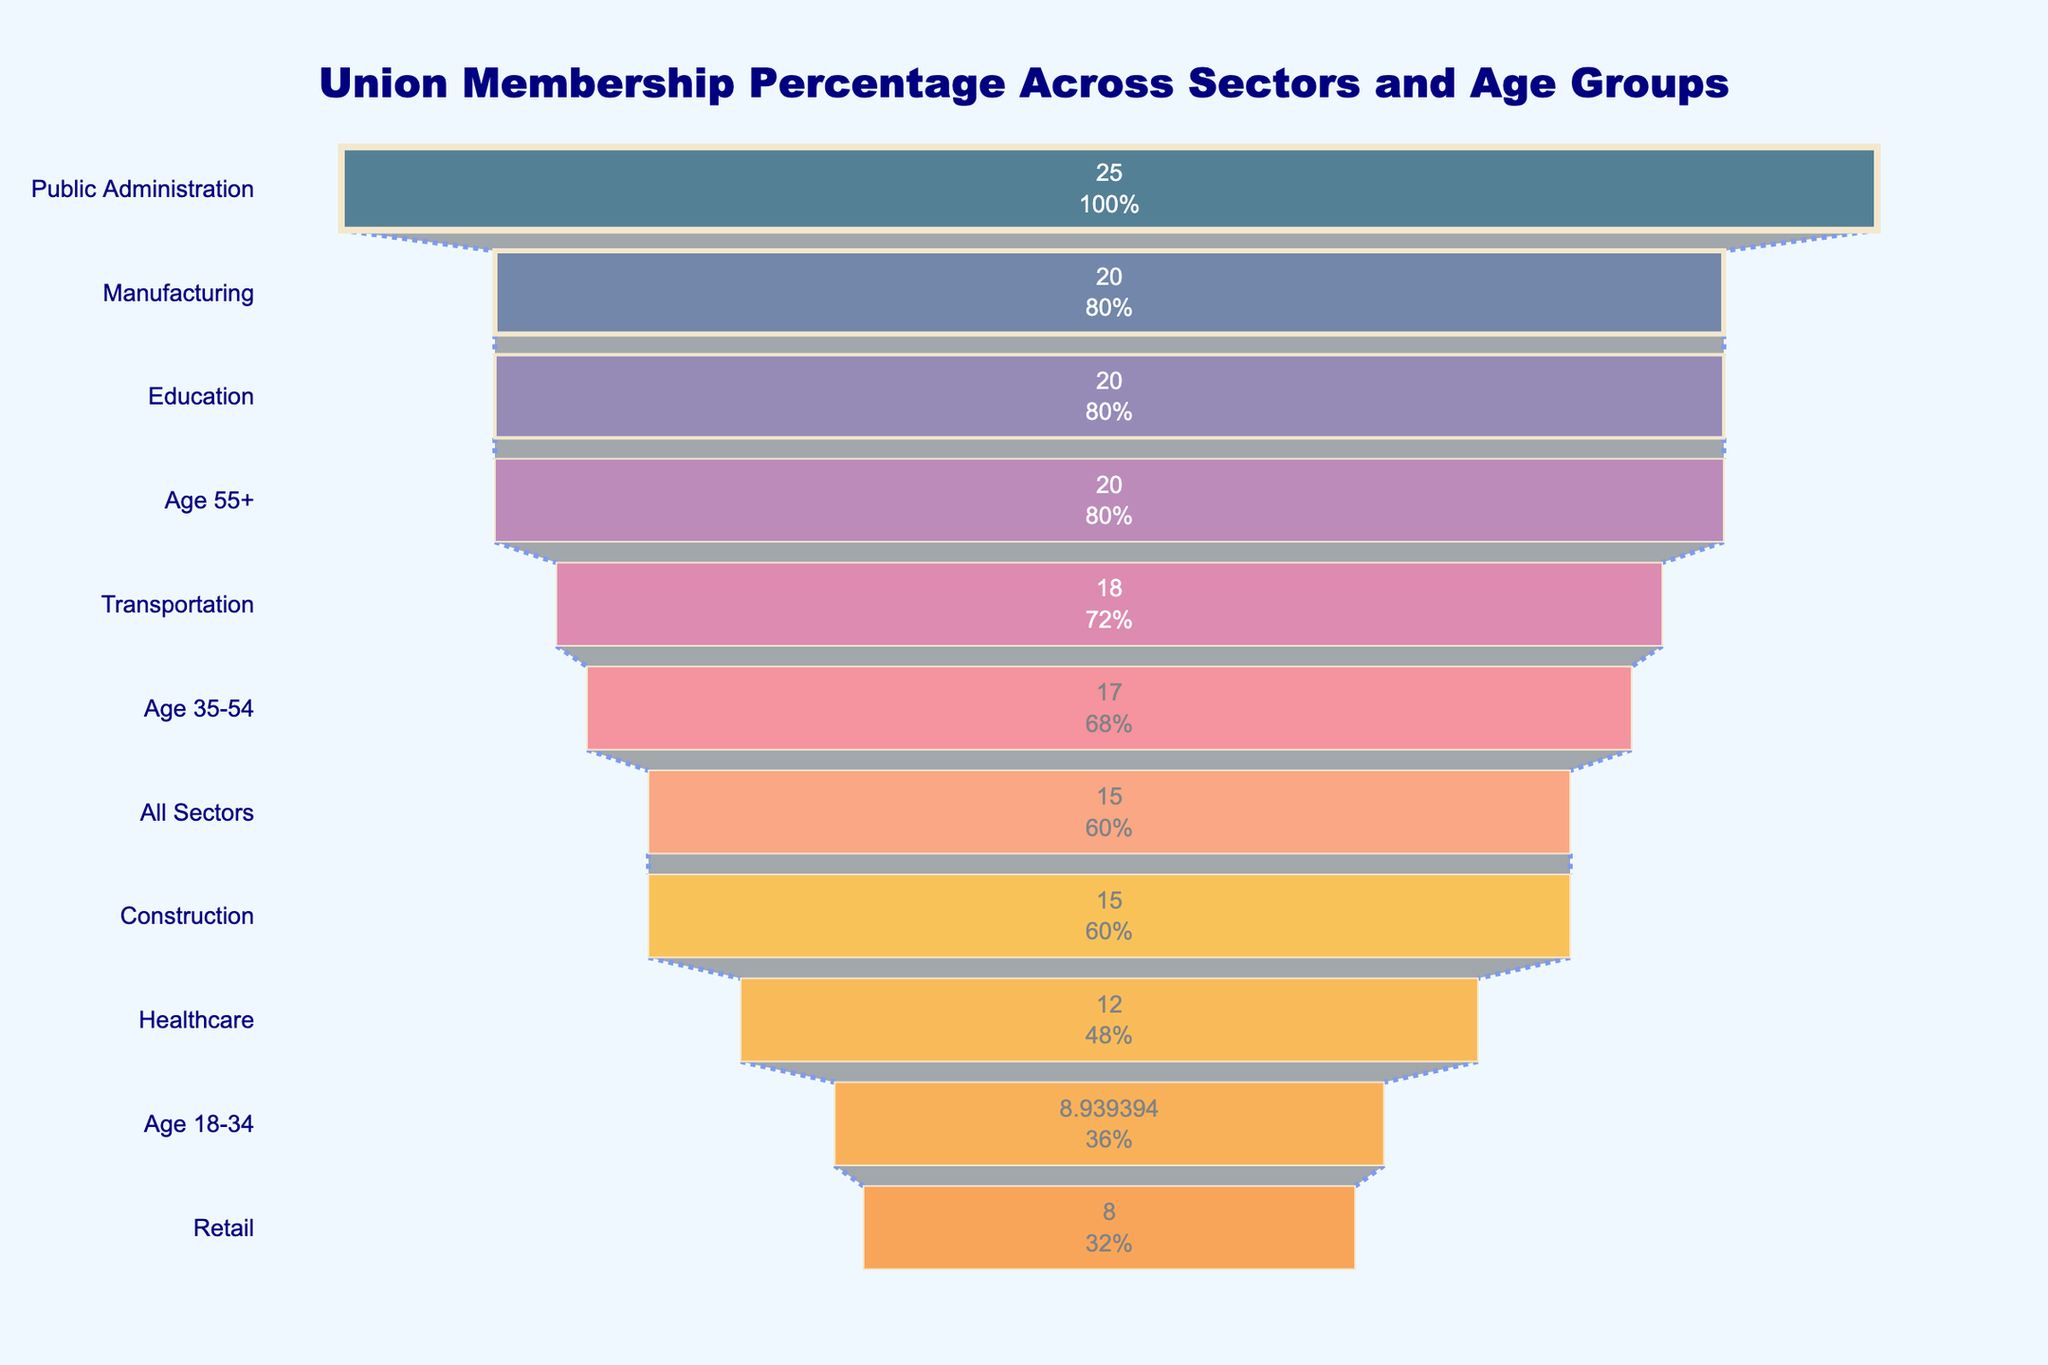What is the title of the funnel chart? The title is usually found at the top of the chart. From the provided code, we know that it is displayed prominently.
Answer: Union Membership Percentage Across Sectors and Age Groups Which sector has the highest percentage of union members? To find this, look at the topmost bar of the funnel chart, as it represents the highest percentage.
Answer: Public Administration How does the percentage of union members in Healthcare compare to that in Retail? Identify the percentages for Healthcare and Retail from the bars in the chart and compare them. Healthcare has a higher percentage than Retail.
Answer: Healthcare > Retail What is the percentage of union members in the Manufacturing sector? Locate the Manufacturing sector in the chart and read its corresponding percentage.
Answer: 20% How does union membership in the Age 55+ group compare to the Age 18-34 group? Compare the percentage of union membership for both age groups by finding their respective bars in the funnel chart. Age 55+ has a higher percentage than Age 18-34.
Answer: Age 55+ > Age 18-34 Which sector has the lowest percentage of union members? To find this, look at the bottommost bar of the funnel chart, as it represents the lowest percentage.
Answer: Retail What is the total percentage range covered by the sectors displayed? Find the percentage values of the highest and lowest union memberships and calculate the difference between them. The highest is Public Administration (25%), and the lowest is Retail (8%), so 25% - 8% = 17%.
Answer: 17% What is the average percentage of union members for the sectors in the chart? Add up the percentages for all sectors and divide by the number of sectors provided. These sectors and percentages are: Manufacturing (20%), Public Administration (25%), Education (20%), Transportation (18%), Construction (15%), Healthcare (12%), Retail (8%). Thus, the average is (20 + 25 + 20 + 18 + 15 + 12 + 8)/7 = 17%.
Answer: 17% Which age group has the lowest union membership percentage? Locate all age groups and compare their percentages, identifying the lowest value.
Answer: Age 18-34 What is the percentage difference in union memberships between the All Sectors category and the Age 35-54 group? Find the percentages for both All Sectors and Age 35-54, then calculate the difference. All Sectors (15%), Age 35-54 (17%). Thus, 17% - 15% = 2%.
Answer: 2% What is the cumulative percentage of union membership for Construction and Education combined? Add the percentage values for Construction (15%) and Education (20%). Thus, 15% + 20% = 35%.
Answer: 35% 